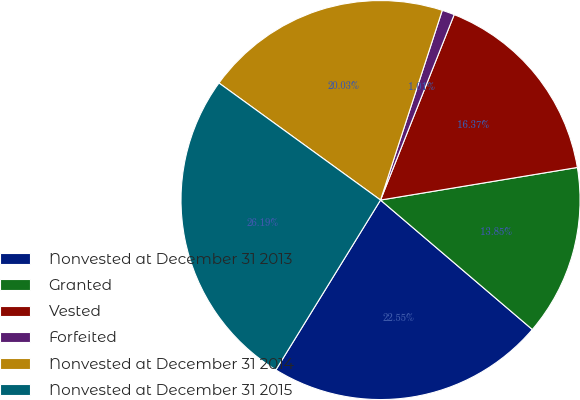Convert chart. <chart><loc_0><loc_0><loc_500><loc_500><pie_chart><fcel>Nonvested at December 31 2013<fcel>Granted<fcel>Vested<fcel>Forfeited<fcel>Nonvested at December 31 2014<fcel>Nonvested at December 31 2015<nl><fcel>22.55%<fcel>13.85%<fcel>16.37%<fcel>1.01%<fcel>20.03%<fcel>26.19%<nl></chart> 